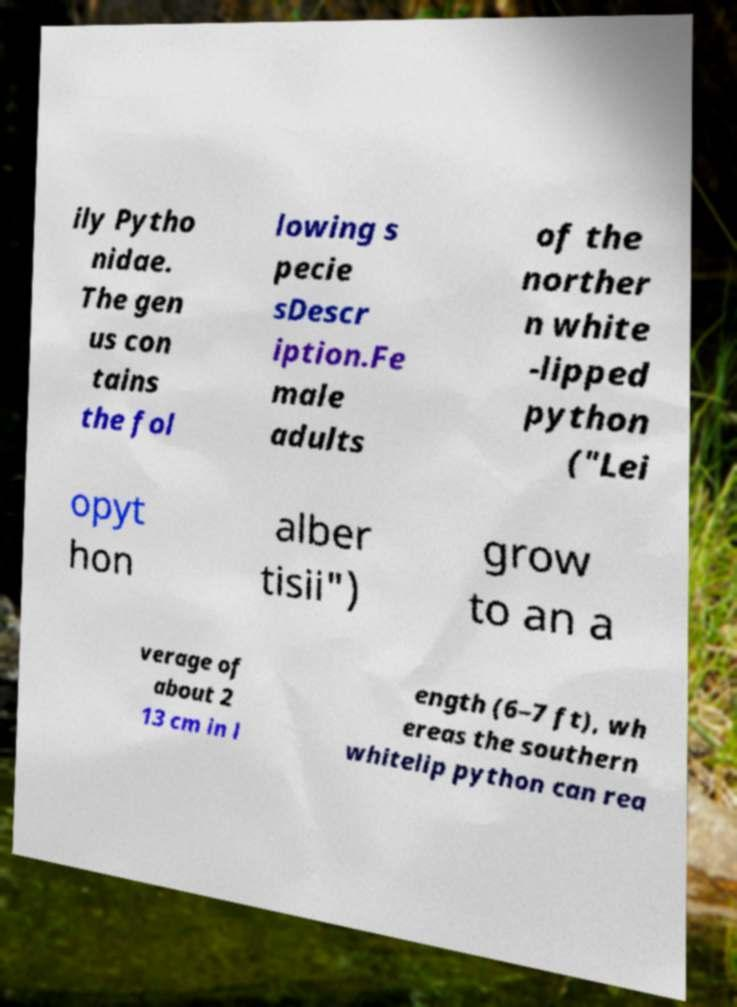Can you read and provide the text displayed in the image?This photo seems to have some interesting text. Can you extract and type it out for me? ily Pytho nidae. The gen us con tains the fol lowing s pecie sDescr iption.Fe male adults of the norther n white -lipped python ("Lei opyt hon alber tisii") grow to an a verage of about 2 13 cm in l ength (6–7 ft), wh ereas the southern whitelip python can rea 